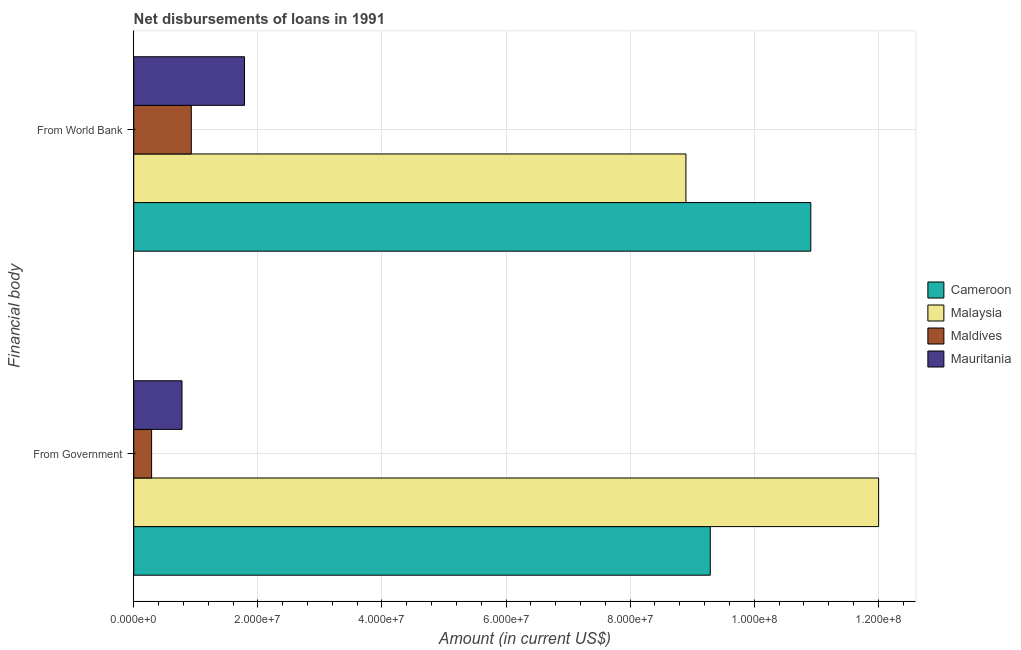How many different coloured bars are there?
Offer a very short reply. 4. How many bars are there on the 1st tick from the bottom?
Your answer should be compact. 4. What is the label of the 2nd group of bars from the top?
Keep it short and to the point. From Government. What is the net disbursements of loan from world bank in Maldives?
Give a very brief answer. 9.28e+06. Across all countries, what is the maximum net disbursements of loan from government?
Your answer should be compact. 1.20e+08. Across all countries, what is the minimum net disbursements of loan from world bank?
Provide a succinct answer. 9.28e+06. In which country was the net disbursements of loan from government maximum?
Keep it short and to the point. Malaysia. In which country was the net disbursements of loan from government minimum?
Your answer should be compact. Maldives. What is the total net disbursements of loan from world bank in the graph?
Offer a terse response. 2.25e+08. What is the difference between the net disbursements of loan from world bank in Mauritania and that in Malaysia?
Ensure brevity in your answer.  -7.11e+07. What is the difference between the net disbursements of loan from government in Maldives and the net disbursements of loan from world bank in Mauritania?
Your answer should be compact. -1.50e+07. What is the average net disbursements of loan from government per country?
Give a very brief answer. 5.59e+07. What is the difference between the net disbursements of loan from world bank and net disbursements of loan from government in Malaysia?
Make the answer very short. -3.11e+07. What is the ratio of the net disbursements of loan from world bank in Maldives to that in Malaysia?
Offer a very short reply. 0.1. In how many countries, is the net disbursements of loan from world bank greater than the average net disbursements of loan from world bank taken over all countries?
Offer a terse response. 2. What does the 1st bar from the top in From World Bank represents?
Ensure brevity in your answer.  Mauritania. What does the 1st bar from the bottom in From World Bank represents?
Provide a succinct answer. Cameroon. Are all the bars in the graph horizontal?
Your response must be concise. Yes. How many countries are there in the graph?
Your answer should be very brief. 4. Does the graph contain any zero values?
Your answer should be compact. No. Does the graph contain grids?
Your answer should be compact. Yes. How are the legend labels stacked?
Offer a terse response. Vertical. What is the title of the graph?
Keep it short and to the point. Net disbursements of loans in 1991. Does "Cayman Islands" appear as one of the legend labels in the graph?
Your answer should be very brief. No. What is the label or title of the Y-axis?
Provide a succinct answer. Financial body. What is the Amount (in current US$) of Cameroon in From Government?
Offer a terse response. 9.29e+07. What is the Amount (in current US$) in Malaysia in From Government?
Provide a succinct answer. 1.20e+08. What is the Amount (in current US$) in Maldives in From Government?
Make the answer very short. 2.88e+06. What is the Amount (in current US$) in Mauritania in From Government?
Keep it short and to the point. 7.78e+06. What is the Amount (in current US$) of Cameroon in From World Bank?
Your response must be concise. 1.09e+08. What is the Amount (in current US$) of Malaysia in From World Bank?
Make the answer very short. 8.90e+07. What is the Amount (in current US$) of Maldives in From World Bank?
Provide a short and direct response. 9.28e+06. What is the Amount (in current US$) of Mauritania in From World Bank?
Your answer should be very brief. 1.79e+07. Across all Financial body, what is the maximum Amount (in current US$) of Cameroon?
Ensure brevity in your answer.  1.09e+08. Across all Financial body, what is the maximum Amount (in current US$) in Malaysia?
Provide a succinct answer. 1.20e+08. Across all Financial body, what is the maximum Amount (in current US$) in Maldives?
Make the answer very short. 9.28e+06. Across all Financial body, what is the maximum Amount (in current US$) of Mauritania?
Give a very brief answer. 1.79e+07. Across all Financial body, what is the minimum Amount (in current US$) in Cameroon?
Offer a very short reply. 9.29e+07. Across all Financial body, what is the minimum Amount (in current US$) in Malaysia?
Offer a very short reply. 8.90e+07. Across all Financial body, what is the minimum Amount (in current US$) of Maldives?
Ensure brevity in your answer.  2.88e+06. Across all Financial body, what is the minimum Amount (in current US$) in Mauritania?
Make the answer very short. 7.78e+06. What is the total Amount (in current US$) in Cameroon in the graph?
Your response must be concise. 2.02e+08. What is the total Amount (in current US$) of Malaysia in the graph?
Give a very brief answer. 2.09e+08. What is the total Amount (in current US$) of Maldives in the graph?
Your answer should be compact. 1.22e+07. What is the total Amount (in current US$) in Mauritania in the graph?
Keep it short and to the point. 2.56e+07. What is the difference between the Amount (in current US$) in Cameroon in From Government and that in From World Bank?
Make the answer very short. -1.62e+07. What is the difference between the Amount (in current US$) of Malaysia in From Government and that in From World Bank?
Give a very brief answer. 3.11e+07. What is the difference between the Amount (in current US$) in Maldives in From Government and that in From World Bank?
Provide a succinct answer. -6.40e+06. What is the difference between the Amount (in current US$) in Mauritania in From Government and that in From World Bank?
Ensure brevity in your answer.  -1.01e+07. What is the difference between the Amount (in current US$) in Cameroon in From Government and the Amount (in current US$) in Malaysia in From World Bank?
Provide a succinct answer. 3.92e+06. What is the difference between the Amount (in current US$) in Cameroon in From Government and the Amount (in current US$) in Maldives in From World Bank?
Your response must be concise. 8.36e+07. What is the difference between the Amount (in current US$) of Cameroon in From Government and the Amount (in current US$) of Mauritania in From World Bank?
Keep it short and to the point. 7.51e+07. What is the difference between the Amount (in current US$) in Malaysia in From Government and the Amount (in current US$) in Maldives in From World Bank?
Provide a short and direct response. 1.11e+08. What is the difference between the Amount (in current US$) in Malaysia in From Government and the Amount (in current US$) in Mauritania in From World Bank?
Keep it short and to the point. 1.02e+08. What is the difference between the Amount (in current US$) in Maldives in From Government and the Amount (in current US$) in Mauritania in From World Bank?
Your answer should be very brief. -1.50e+07. What is the average Amount (in current US$) of Cameroon per Financial body?
Your answer should be very brief. 1.01e+08. What is the average Amount (in current US$) of Malaysia per Financial body?
Give a very brief answer. 1.05e+08. What is the average Amount (in current US$) in Maldives per Financial body?
Ensure brevity in your answer.  6.08e+06. What is the average Amount (in current US$) of Mauritania per Financial body?
Keep it short and to the point. 1.28e+07. What is the difference between the Amount (in current US$) in Cameroon and Amount (in current US$) in Malaysia in From Government?
Ensure brevity in your answer.  -2.71e+07. What is the difference between the Amount (in current US$) in Cameroon and Amount (in current US$) in Maldives in From Government?
Your answer should be compact. 9.00e+07. What is the difference between the Amount (in current US$) of Cameroon and Amount (in current US$) of Mauritania in From Government?
Keep it short and to the point. 8.51e+07. What is the difference between the Amount (in current US$) in Malaysia and Amount (in current US$) in Maldives in From Government?
Provide a short and direct response. 1.17e+08. What is the difference between the Amount (in current US$) of Malaysia and Amount (in current US$) of Mauritania in From Government?
Offer a terse response. 1.12e+08. What is the difference between the Amount (in current US$) in Maldives and Amount (in current US$) in Mauritania in From Government?
Your answer should be very brief. -4.90e+06. What is the difference between the Amount (in current US$) of Cameroon and Amount (in current US$) of Malaysia in From World Bank?
Provide a short and direct response. 2.01e+07. What is the difference between the Amount (in current US$) in Cameroon and Amount (in current US$) in Maldives in From World Bank?
Provide a short and direct response. 9.98e+07. What is the difference between the Amount (in current US$) in Cameroon and Amount (in current US$) in Mauritania in From World Bank?
Make the answer very short. 9.13e+07. What is the difference between the Amount (in current US$) of Malaysia and Amount (in current US$) of Maldives in From World Bank?
Give a very brief answer. 7.97e+07. What is the difference between the Amount (in current US$) of Malaysia and Amount (in current US$) of Mauritania in From World Bank?
Give a very brief answer. 7.11e+07. What is the difference between the Amount (in current US$) in Maldives and Amount (in current US$) in Mauritania in From World Bank?
Your answer should be very brief. -8.58e+06. What is the ratio of the Amount (in current US$) of Cameroon in From Government to that in From World Bank?
Offer a terse response. 0.85. What is the ratio of the Amount (in current US$) in Malaysia in From Government to that in From World Bank?
Your answer should be compact. 1.35. What is the ratio of the Amount (in current US$) in Maldives in From Government to that in From World Bank?
Your answer should be compact. 0.31. What is the ratio of the Amount (in current US$) in Mauritania in From Government to that in From World Bank?
Your answer should be very brief. 0.44. What is the difference between the highest and the second highest Amount (in current US$) in Cameroon?
Keep it short and to the point. 1.62e+07. What is the difference between the highest and the second highest Amount (in current US$) of Malaysia?
Ensure brevity in your answer.  3.11e+07. What is the difference between the highest and the second highest Amount (in current US$) of Maldives?
Make the answer very short. 6.40e+06. What is the difference between the highest and the second highest Amount (in current US$) of Mauritania?
Ensure brevity in your answer.  1.01e+07. What is the difference between the highest and the lowest Amount (in current US$) in Cameroon?
Your answer should be compact. 1.62e+07. What is the difference between the highest and the lowest Amount (in current US$) of Malaysia?
Offer a very short reply. 3.11e+07. What is the difference between the highest and the lowest Amount (in current US$) of Maldives?
Provide a succinct answer. 6.40e+06. What is the difference between the highest and the lowest Amount (in current US$) in Mauritania?
Offer a very short reply. 1.01e+07. 